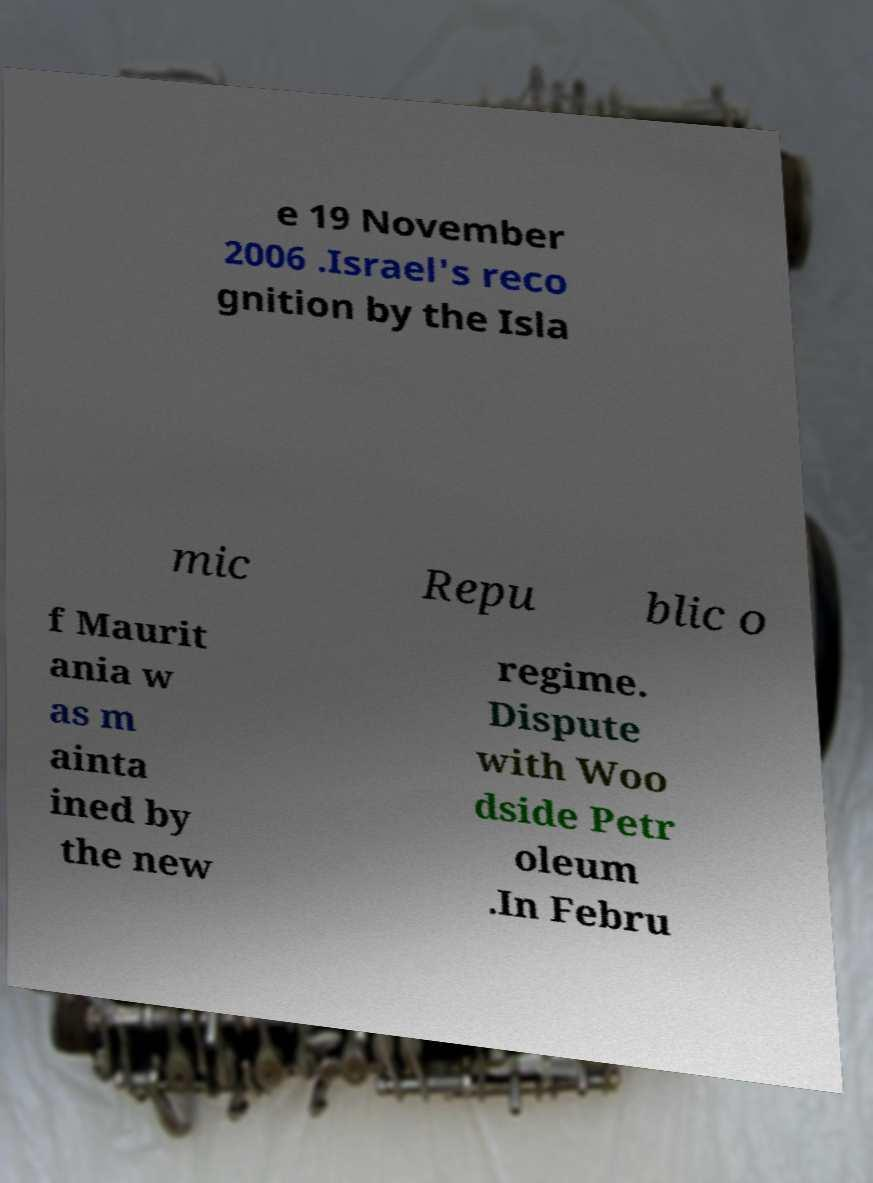For documentation purposes, I need the text within this image transcribed. Could you provide that? e 19 November 2006 .Israel's reco gnition by the Isla mic Repu blic o f Maurit ania w as m ainta ined by the new regime. Dispute with Woo dside Petr oleum .In Febru 